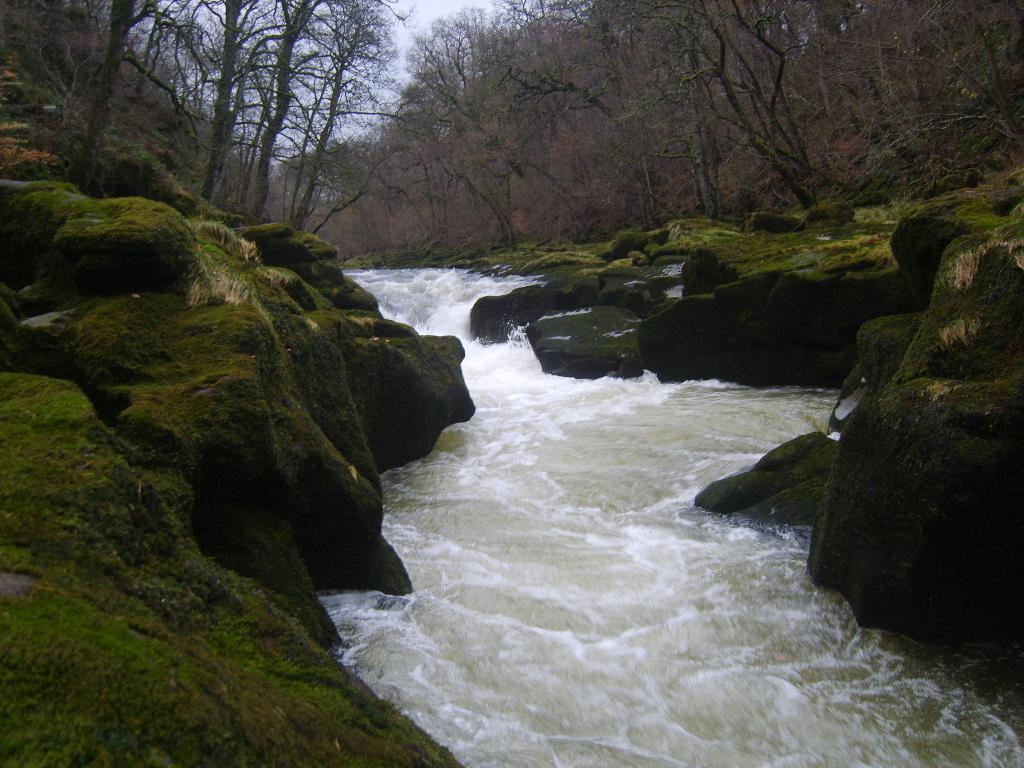In one or two sentences, can you explain what this image depicts? In this image we can see water in between the rocks, there we can see few trees, grass and the sky. 